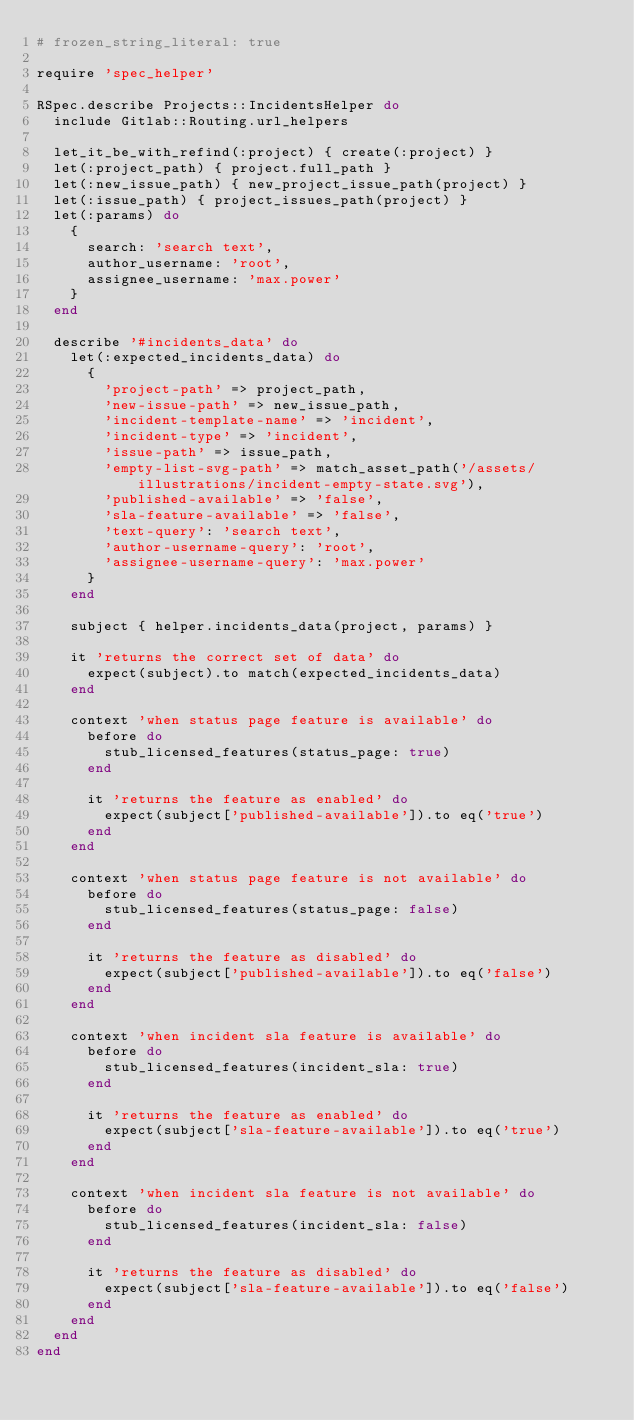Convert code to text. <code><loc_0><loc_0><loc_500><loc_500><_Ruby_># frozen_string_literal: true

require 'spec_helper'

RSpec.describe Projects::IncidentsHelper do
  include Gitlab::Routing.url_helpers

  let_it_be_with_refind(:project) { create(:project) }
  let(:project_path) { project.full_path }
  let(:new_issue_path) { new_project_issue_path(project) }
  let(:issue_path) { project_issues_path(project) }
  let(:params) do
    {
      search: 'search text',
      author_username: 'root',
      assignee_username: 'max.power'
    }
  end

  describe '#incidents_data' do
    let(:expected_incidents_data) do
      {
        'project-path' => project_path,
        'new-issue-path' => new_issue_path,
        'incident-template-name' => 'incident',
        'incident-type' => 'incident',
        'issue-path' => issue_path,
        'empty-list-svg-path' => match_asset_path('/assets/illustrations/incident-empty-state.svg'),
        'published-available' => 'false',
        'sla-feature-available' => 'false',
        'text-query': 'search text',
        'author-username-query': 'root',
        'assignee-username-query': 'max.power'
      }
    end

    subject { helper.incidents_data(project, params) }

    it 'returns the correct set of data' do
      expect(subject).to match(expected_incidents_data)
    end

    context 'when status page feature is available' do
      before do
        stub_licensed_features(status_page: true)
      end

      it 'returns the feature as enabled' do
        expect(subject['published-available']).to eq('true')
      end
    end

    context 'when status page feature is not available' do
      before do
        stub_licensed_features(status_page: false)
      end

      it 'returns the feature as disabled' do
        expect(subject['published-available']).to eq('false')
      end
    end

    context 'when incident sla feature is available' do
      before do
        stub_licensed_features(incident_sla: true)
      end

      it 'returns the feature as enabled' do
        expect(subject['sla-feature-available']).to eq('true')
      end
    end

    context 'when incident sla feature is not available' do
      before do
        stub_licensed_features(incident_sla: false)
      end

      it 'returns the feature as disabled' do
        expect(subject['sla-feature-available']).to eq('false')
      end
    end
  end
end
</code> 